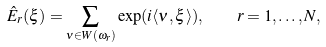<formula> <loc_0><loc_0><loc_500><loc_500>\hat { E } _ { r } ( \xi ) = \sum _ { \nu \in W ( \omega _ { r } ) } \exp ( i \langle \nu , \xi \rangle ) , \quad r = 1 , \dots , N ,</formula> 